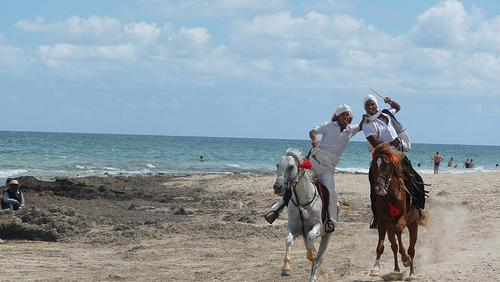How many horses are there in the image and what are their colors? There are two horses, one is brown and the other is white. What type of weather can be inferred from the image, and why? It appears to be a sunny day because the photo was taken during the day, and there are clear, bright colors and some fluffy clouds in the sky. How many people can you spot in the ocean and describe their situation? There are two people, one solitary swimmer to the left of the horses, and another person standing by the water with hands on their hips. Mention any notable accessories or details about the horse riders. One of the riders is holding a stick, and the white horse has a red ribbon. Are there any other people or groups on the beach, apart from the horse riders? Yes, there are people playing, swimming in the background, and a man sitting on the beach wearing a hat, blue long sleeve shirt, and vest. Provide a brief description of the clothing worn by the men on horses. One man is wearing an all-white outfit with white headwear, while the other man has a white shirt, black pants, and a shoulder bag. What are the main colors and elements of the natural scenery? The main colors are blue in the sky and ocean, white fluffy clouds, and sandy tan on the beach. Identify the main activity taking place on the beach. Two men are riding horses, with one on a white horse and the other on a brown horse, galloping across the beach. Provide an overall assessment of the image quality. The image quality is high, with clear and vivid details of the subjects and the background, enhancing the visual appeal. What is the general mood or sentiment of the image? The mood is lively, energetic, and fun, with various outdoor activities taking place on the beach. 